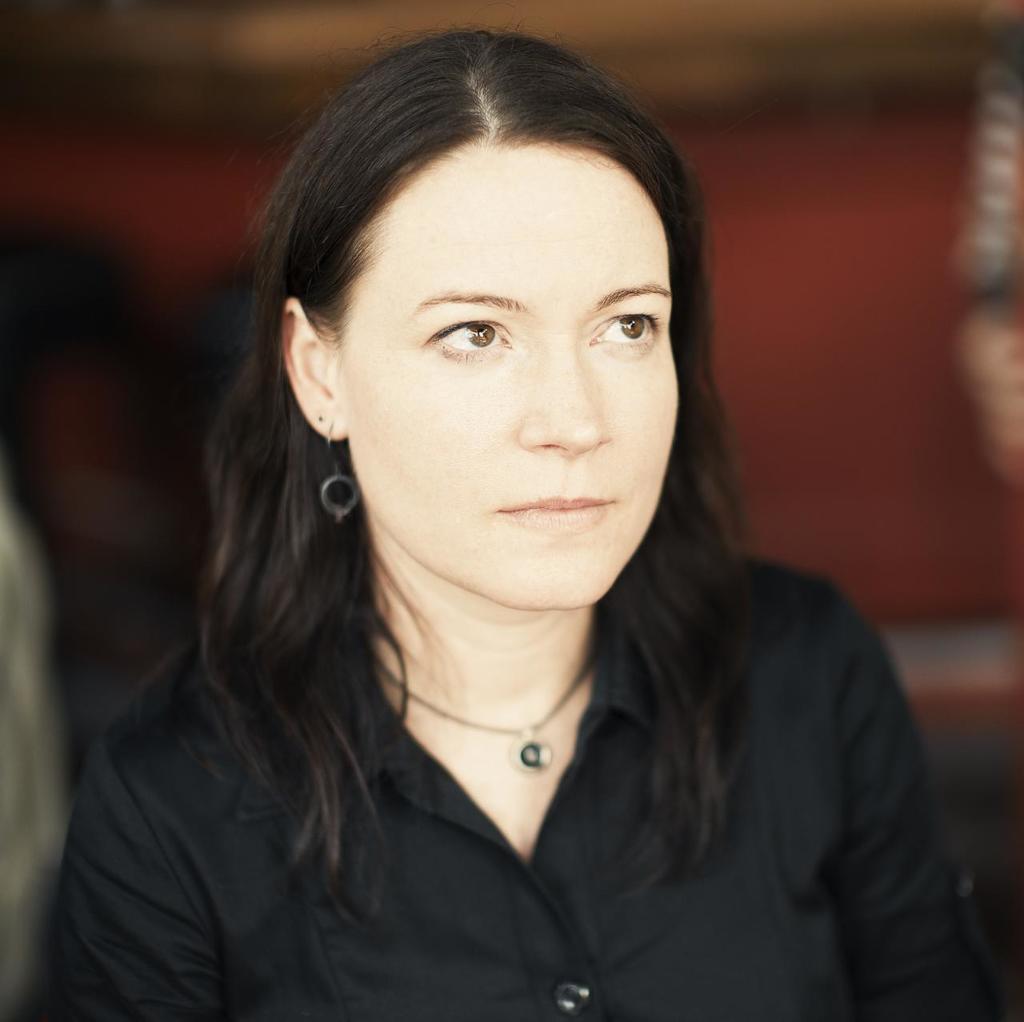Describe this image in one or two sentences. In this picture I can see there is a woman and she is wearing a black shirt and looking at right side and the backdrop is blurred. 